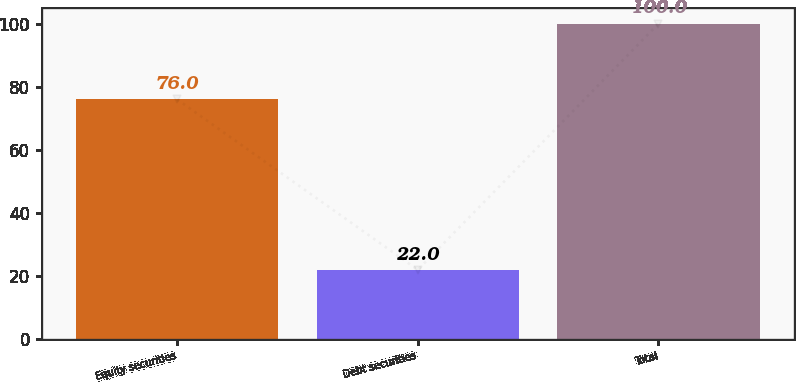Convert chart to OTSL. <chart><loc_0><loc_0><loc_500><loc_500><bar_chart><fcel>Equity securities<fcel>Debt securities<fcel>Total<nl><fcel>76<fcel>22<fcel>100<nl></chart> 